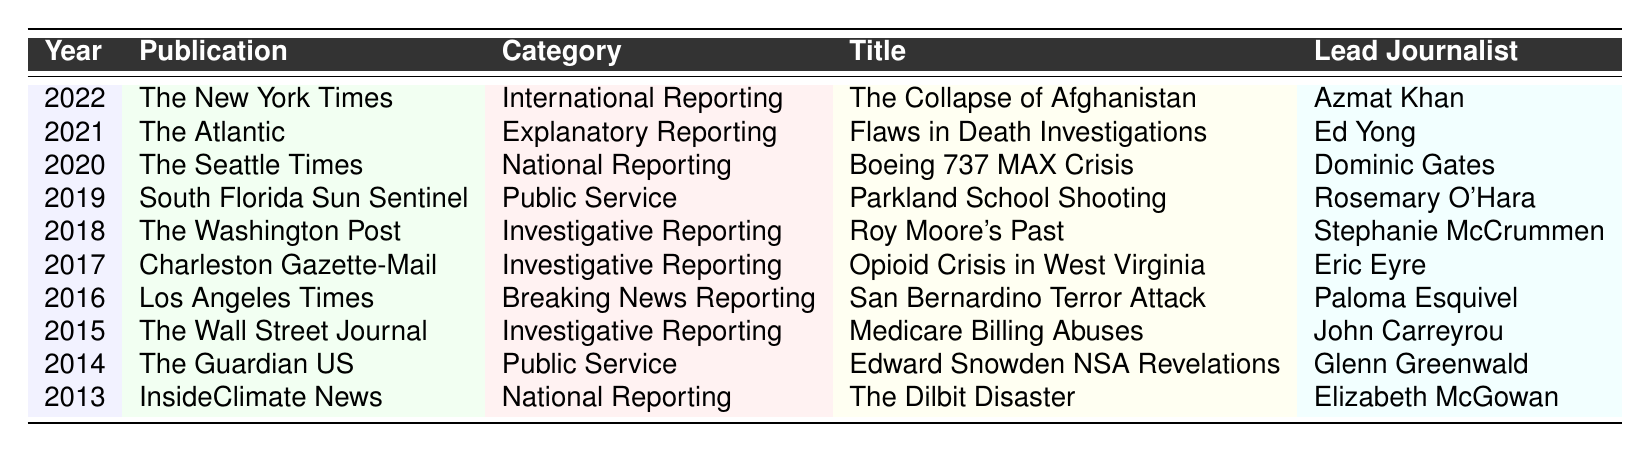What was the title of the Pulitzer Prize-winning article published in 2022? According to the table, the article published in 2022 is titled "The Collapse of Afghanistan."
Answer: The Collapse of Afghanistan Who was the lead journalist for the 2020 Pulitzer Prize-winning article? From the table, the lead journalist for the 2020 article "Boeing 737 MAX Crisis" is Dominic Gates.
Answer: Dominic Gates Which publication won the Pulitzer Prize for Public Service in 2019? The table indicates that the South Florida Sun Sentinel won the Pulitzer Prize for Public Service in 2019 for the article titled "Parkland School Shooting."
Answer: South Florida Sun Sentinel How many Pulitzer Prize-winning articles were published between 2020 and 2022? The years 2020, 2021, and 2022 are included. Thus, there are three articles corresponding to these years listed in the table.
Answer: 3 In what category did The Washington Post win the Pulitzer Prize in 2018? The table shows that The Washington Post won the Pulitzer Prize in the category of Investigative Reporting in 2018.
Answer: Investigative Reporting Did any articles focused on the Opioid Crisis receive a Pulitzer Prize? Yes, the table lists an article titled "Opioid Crisis in West Virginia," published by Charleston Gazette-Mail in 2017, under the category Investigative Reporting.
Answer: Yes What is the average year of the articles listed in the table? To calculate the average year, sum all the years (2013 + 2014 + 2015 + 2016 + 2017 + 2018 + 2019 + 2020 + 2021 + 2022 =  20, 035) and divide by the number of articles (10). The average year is 2017.5, which can be rounded to 2018.
Answer: 2018 How many articles were published by The Atlantic in the last decade according to the table? The table indicates that The Atlantic published one winning article in 2021.
Answer: 1 Which category received the most Pulitzer Prize-winning articles in this data set? By reviewing the table, it can be seen that the category "Investigative Reporting" appears three times (2017, 2018, 2015), which is more than any other category.
Answer: Investigative Reporting Was there any Pulitzer Prize-winning article related to the Edward Snowden revelations? Yes, the table shows that "Edward Snowden NSA Revelations" won a Pulitzer Prize for Public Service in 2014, indicating its relation to Snowden's revelations.
Answer: Yes 